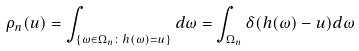<formula> <loc_0><loc_0><loc_500><loc_500>\rho _ { n } ( u ) = \int _ { \{ \omega \in \Omega _ { n } \colon h ( \omega ) = u \} } d \omega = \int _ { \Omega _ { n } } \delta ( h ( \omega ) - u ) d \omega</formula> 